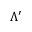Convert formula to latex. <formula><loc_0><loc_0><loc_500><loc_500>\Lambda ^ { \prime }</formula> 